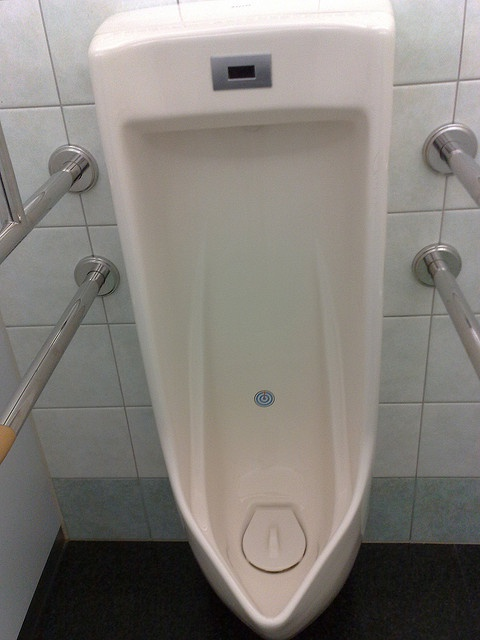Describe the objects in this image and their specific colors. I can see a toilet in darkgray, gray, and white tones in this image. 